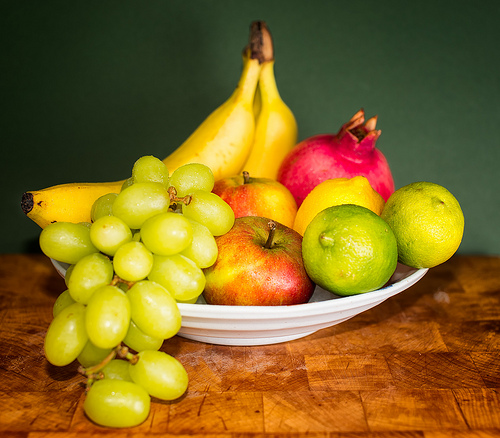<image>
Is the banana behind the grapes? Yes. From this viewpoint, the banana is positioned behind the grapes, with the grapes partially or fully occluding the banana. Is the grapes under the bowl? No. The grapes is not positioned under the bowl. The vertical relationship between these objects is different. Is the grapes under the onion? No. The grapes is not positioned under the onion. The vertical relationship between these objects is different. 